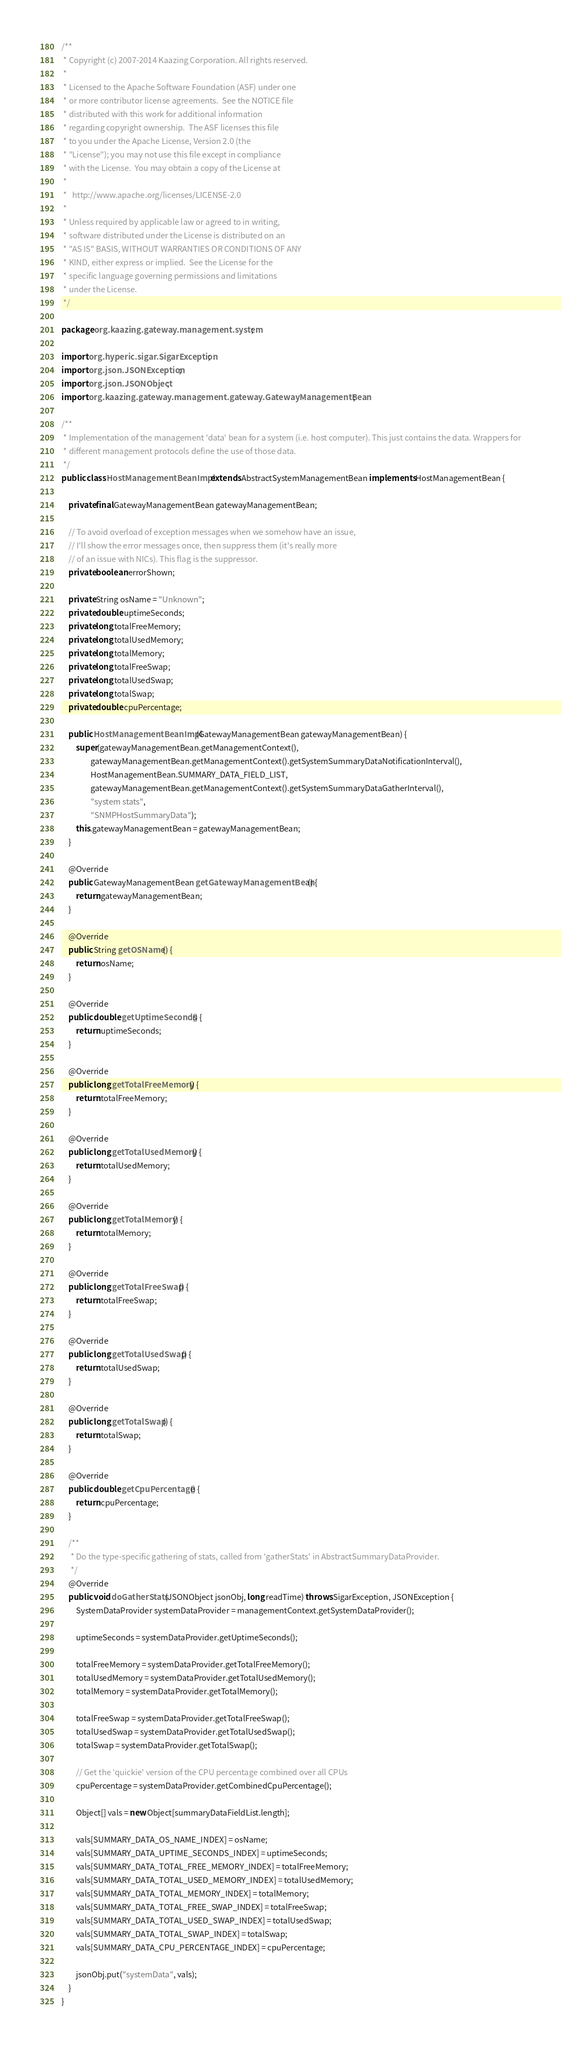<code> <loc_0><loc_0><loc_500><loc_500><_Java_>/**
 * Copyright (c) 2007-2014 Kaazing Corporation. All rights reserved.
 *
 * Licensed to the Apache Software Foundation (ASF) under one
 * or more contributor license agreements.  See the NOTICE file
 * distributed with this work for additional information
 * regarding copyright ownership.  The ASF licenses this file
 * to you under the Apache License, Version 2.0 (the
 * "License"); you may not use this file except in compliance
 * with the License.  You may obtain a copy of the License at
 *
 *   http://www.apache.org/licenses/LICENSE-2.0
 *
 * Unless required by applicable law or agreed to in writing,
 * software distributed under the License is distributed on an
 * "AS IS" BASIS, WITHOUT WARRANTIES OR CONDITIONS OF ANY
 * KIND, either express or implied.  See the License for the
 * specific language governing permissions and limitations
 * under the License.
 */

package org.kaazing.gateway.management.system;

import org.hyperic.sigar.SigarException;
import org.json.JSONException;
import org.json.JSONObject;
import org.kaazing.gateway.management.gateway.GatewayManagementBean;

/**
 * Implementation of the management 'data' bean for a system (i.e. host computer). This just contains the data. Wrappers for
 * different management protocols define the use of those data.
 */
public class HostManagementBeanImpl extends AbstractSystemManagementBean implements HostManagementBean {

    private final GatewayManagementBean gatewayManagementBean;

    // To avoid overload of exception messages when we somehow have an issue,
    // I'll show the error messages once, then suppress them (it's really more
    // of an issue with NICs). This flag is the suppressor.
    private boolean errorShown;

    private String osName = "Unknown";
    private double uptimeSeconds;
    private long totalFreeMemory;
    private long totalUsedMemory;
    private long totalMemory;
    private long totalFreeSwap;
    private long totalUsedSwap;
    private long totalSwap;
    private double cpuPercentage;

    public HostManagementBeanImpl(GatewayManagementBean gatewayManagementBean) {
        super(gatewayManagementBean.getManagementContext(),
                gatewayManagementBean.getManagementContext().getSystemSummaryDataNotificationInterval(),
                HostManagementBean.SUMMARY_DATA_FIELD_LIST,
                gatewayManagementBean.getManagementContext().getSystemSummaryDataGatherInterval(),
                "system stats",
                "SNMPHostSummaryData");
        this.gatewayManagementBean = gatewayManagementBean;
    }

    @Override
    public GatewayManagementBean getGatewayManagementBean() {
        return gatewayManagementBean;
    }

    @Override
    public String getOSName() {
        return osName;
    }

    @Override
    public double getUptimeSeconds() {
        return uptimeSeconds;
    }

    @Override
    public long getTotalFreeMemory() {
        return totalFreeMemory;
    }

    @Override
    public long getTotalUsedMemory() {
        return totalUsedMemory;
    }

    @Override
    public long getTotalMemory() {
        return totalMemory;
    }

    @Override
    public long getTotalFreeSwap() {
        return totalFreeSwap;
    }

    @Override
    public long getTotalUsedSwap() {
        return totalUsedSwap;
    }

    @Override
    public long getTotalSwap() {
        return totalSwap;
    }

    @Override
    public double getCpuPercentage() {
        return cpuPercentage;
    }

    /**
     * Do the type-specific gathering of stats, called from 'gatherStats' in AbstractSummaryDataProvider.
     */
    @Override
    public void doGatherStats(JSONObject jsonObj, long readTime) throws SigarException, JSONException {
        SystemDataProvider systemDataProvider = managementContext.getSystemDataProvider();

        uptimeSeconds = systemDataProvider.getUptimeSeconds();

        totalFreeMemory = systemDataProvider.getTotalFreeMemory();
        totalUsedMemory = systemDataProvider.getTotalUsedMemory();
        totalMemory = systemDataProvider.getTotalMemory();

        totalFreeSwap = systemDataProvider.getTotalFreeSwap();
        totalUsedSwap = systemDataProvider.getTotalUsedSwap();
        totalSwap = systemDataProvider.getTotalSwap();

        // Get the 'quickie' version of the CPU percentage combined over all CPUs
        cpuPercentage = systemDataProvider.getCombinedCpuPercentage();

        Object[] vals = new Object[summaryDataFieldList.length];

        vals[SUMMARY_DATA_OS_NAME_INDEX] = osName;
        vals[SUMMARY_DATA_UPTIME_SECONDS_INDEX] = uptimeSeconds;
        vals[SUMMARY_DATA_TOTAL_FREE_MEMORY_INDEX] = totalFreeMemory;
        vals[SUMMARY_DATA_TOTAL_USED_MEMORY_INDEX] = totalUsedMemory;
        vals[SUMMARY_DATA_TOTAL_MEMORY_INDEX] = totalMemory;
        vals[SUMMARY_DATA_TOTAL_FREE_SWAP_INDEX] = totalFreeSwap;
        vals[SUMMARY_DATA_TOTAL_USED_SWAP_INDEX] = totalUsedSwap;
        vals[SUMMARY_DATA_TOTAL_SWAP_INDEX] = totalSwap;
        vals[SUMMARY_DATA_CPU_PERCENTAGE_INDEX] = cpuPercentage;

        jsonObj.put("systemData", vals);
    }
}
</code> 